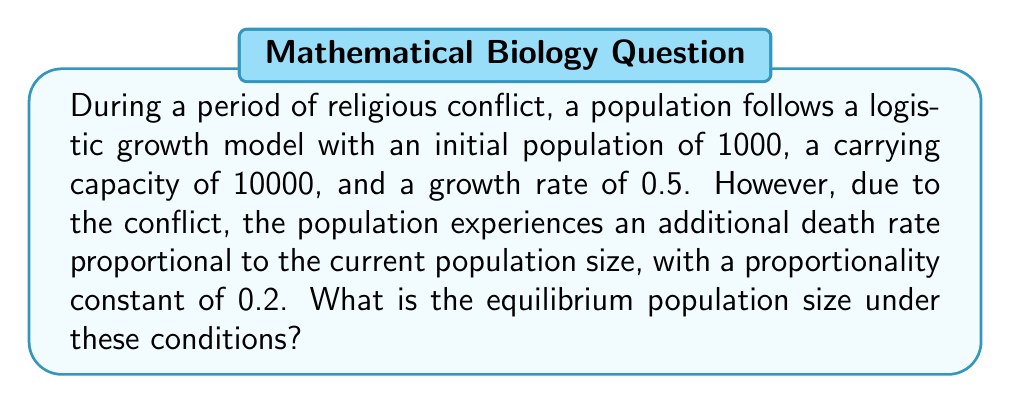Give your solution to this math problem. To solve this problem, we need to modify the standard logistic growth equation to account for the additional death rate due to religious conflict. Let's approach this step-by-step:

1. The standard logistic growth equation is:

   $$\frac{dP}{dt} = rP(1 - \frac{P}{K})$$

   where $P$ is the population, $r$ is the growth rate, and $K$ is the carrying capacity.

2. We need to modify this equation to include the additional death rate. The modified equation becomes:

   $$\frac{dP}{dt} = rP(1 - \frac{P}{K}) - dP$$

   where $d$ is the proportionality constant for the additional death rate (0.2 in this case).

3. At equilibrium, $\frac{dP}{dt} = 0$, so we can set the equation equal to zero:

   $$0 = rP(1 - \frac{P}{K}) - dP$$

4. Factoring out $P$:

   $$0 = P(r(1 - \frac{P}{K}) - d)$$

5. For this to be true, either $P = 0$ (trivial solution) or the term in parentheses must be zero. We're interested in the non-trivial solution, so:

   $$r(1 - \frac{P}{K}) - d = 0$$

6. Solving for $P$:

   $$r - \frac{rP}{K} - d = 0$$
   $$r - d = \frac{rP}{K}$$
   $$P = \frac{K(r-d)}{r}$$

7. Plugging in the given values ($K = 10000$, $r = 0.5$, $d = 0.2$):

   $$P = \frac{10000(0.5-0.2)}{0.5} = \frac{10000(0.3)}{0.5} = 6000$$

Therefore, the equilibrium population size under these conditions is 6000.
Answer: 6000 